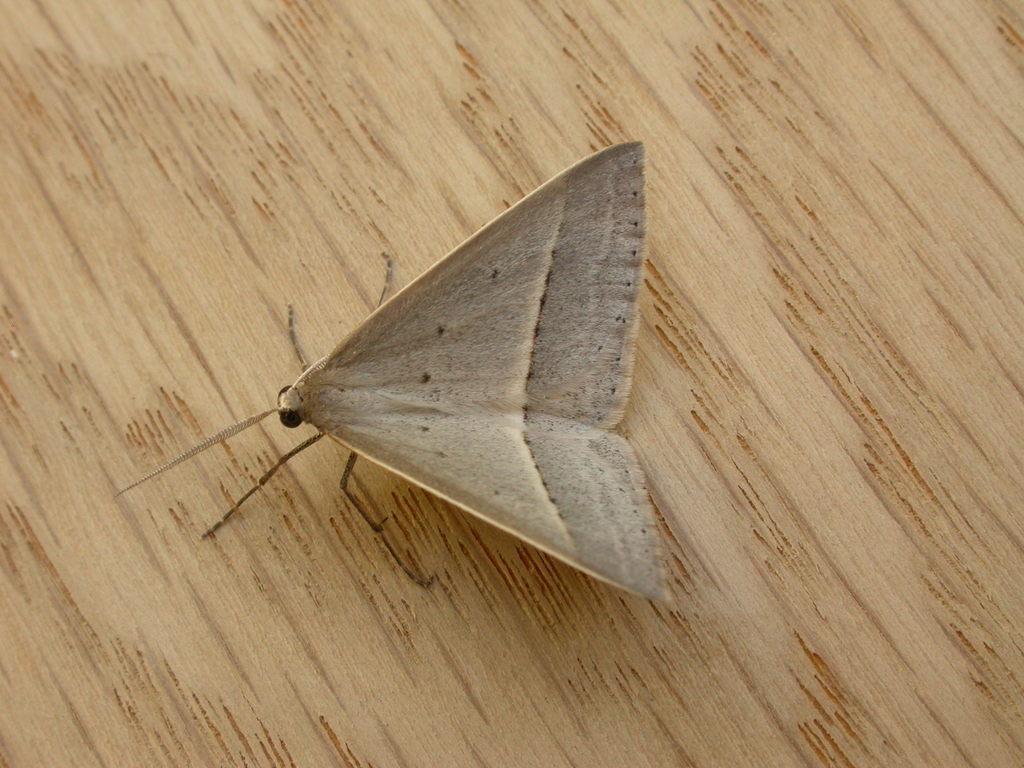How would you summarize this image in a sentence or two? In this picture we can see a butterfly sitting on the wood. 